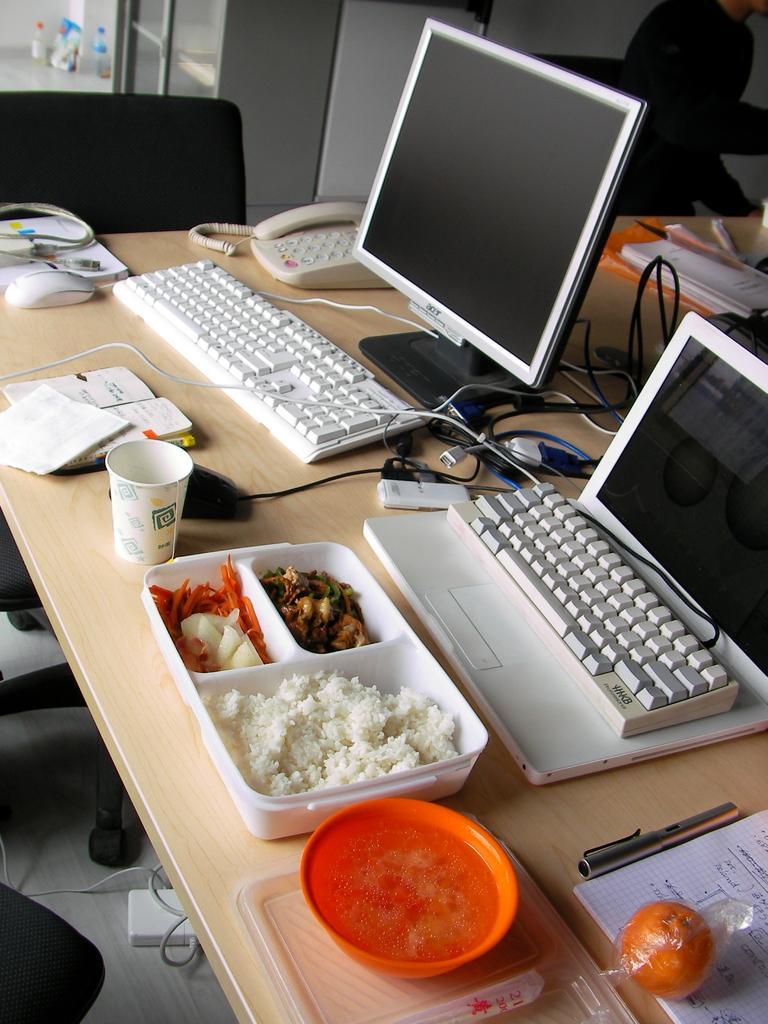Describe this image in one or two sentences. In the picture we can see a table on the table we can see a computer with keyboard, wires, and another computer with keyboard and we can also see a food box, bowl, fruit, pen papers and telephone. There is a chair near to it. 